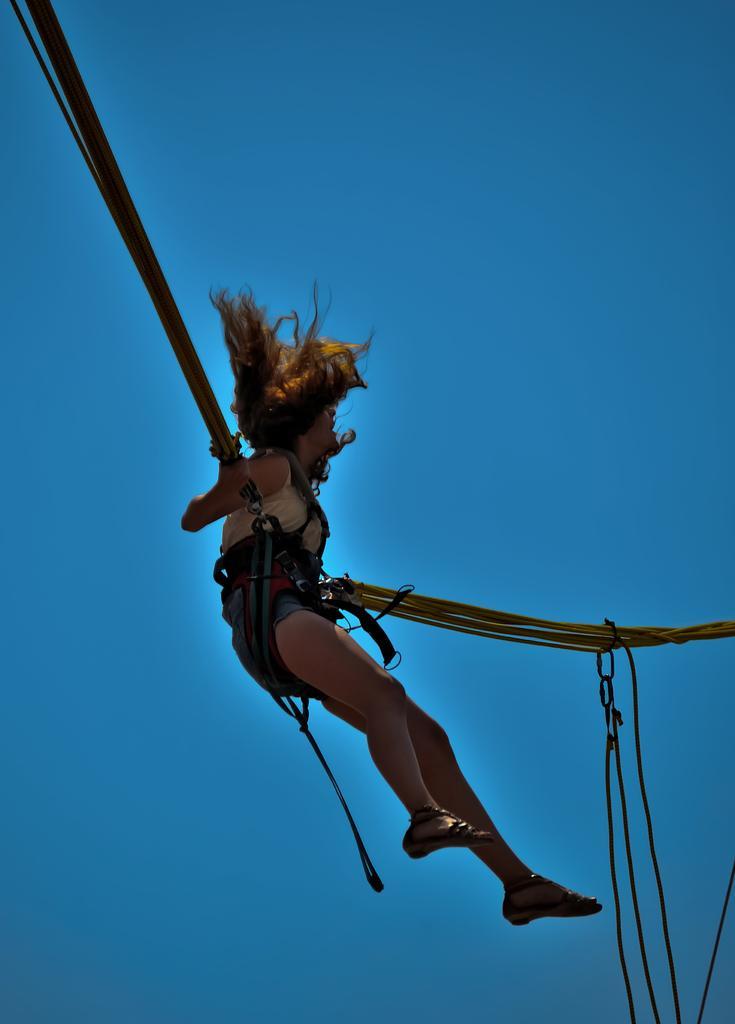Please provide a concise description of this image. In this image we can see a lady performing bungy jump. In the background of the image there is sky. 